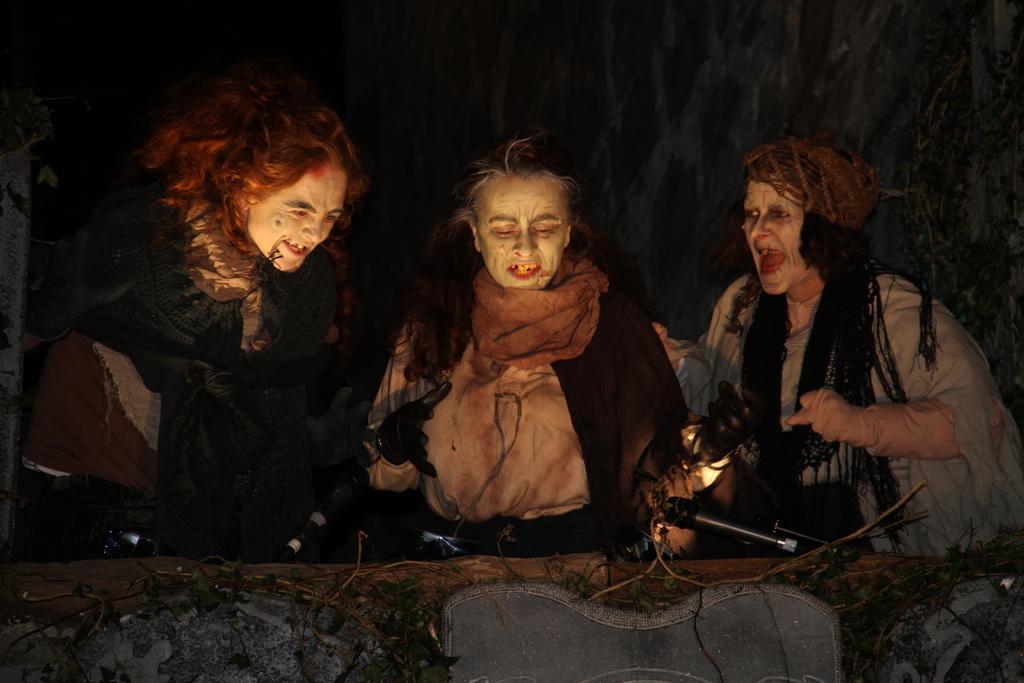Please provide a concise description of this image. In this picture we can see three persons, they wore Halloween costumes, we can see microphones and leaves at the bottom, there is a dark background. 